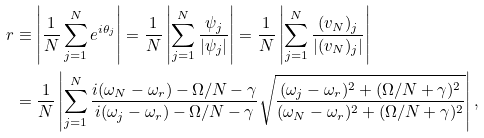Convert formula to latex. <formula><loc_0><loc_0><loc_500><loc_500>r & \equiv \left | \frac { 1 } { N } \sum _ { j = 1 } ^ { N } e ^ { i \theta _ { j } } \right | = \frac { 1 } { N } \left | \sum _ { j = 1 } ^ { N } \frac { \psi _ { j } } { | \psi _ { j } | } \right | = \frac { 1 } { N } \left | \sum _ { j = 1 } ^ { N } \frac { ( v _ { N } ) _ { j } } { | ( v _ { N } ) _ { j } | } \right | \\ & = \frac { 1 } { N } \left | \sum _ { j = 1 } ^ { N } \frac { i ( \omega _ { N } - \omega _ { r } ) - \Omega / N - \gamma } { i ( \omega _ { j } - \omega _ { r } ) - \Omega / N - \gamma } \sqrt { \frac { ( \omega _ { j } - \omega _ { r } ) ^ { 2 } + ( \Omega / N + \gamma ) ^ { 2 } } { ( \omega _ { N } - \omega _ { r } ) ^ { 2 } + ( \Omega / N + \gamma ) ^ { 2 } } } \right | ,</formula> 